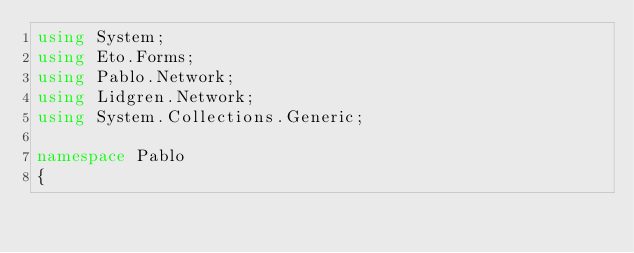<code> <loc_0><loc_0><loc_500><loc_500><_C#_>using System;
using Eto.Forms;
using Pablo.Network;
using Lidgren.Network;
using System.Collections.Generic;

namespace Pablo
{</code> 